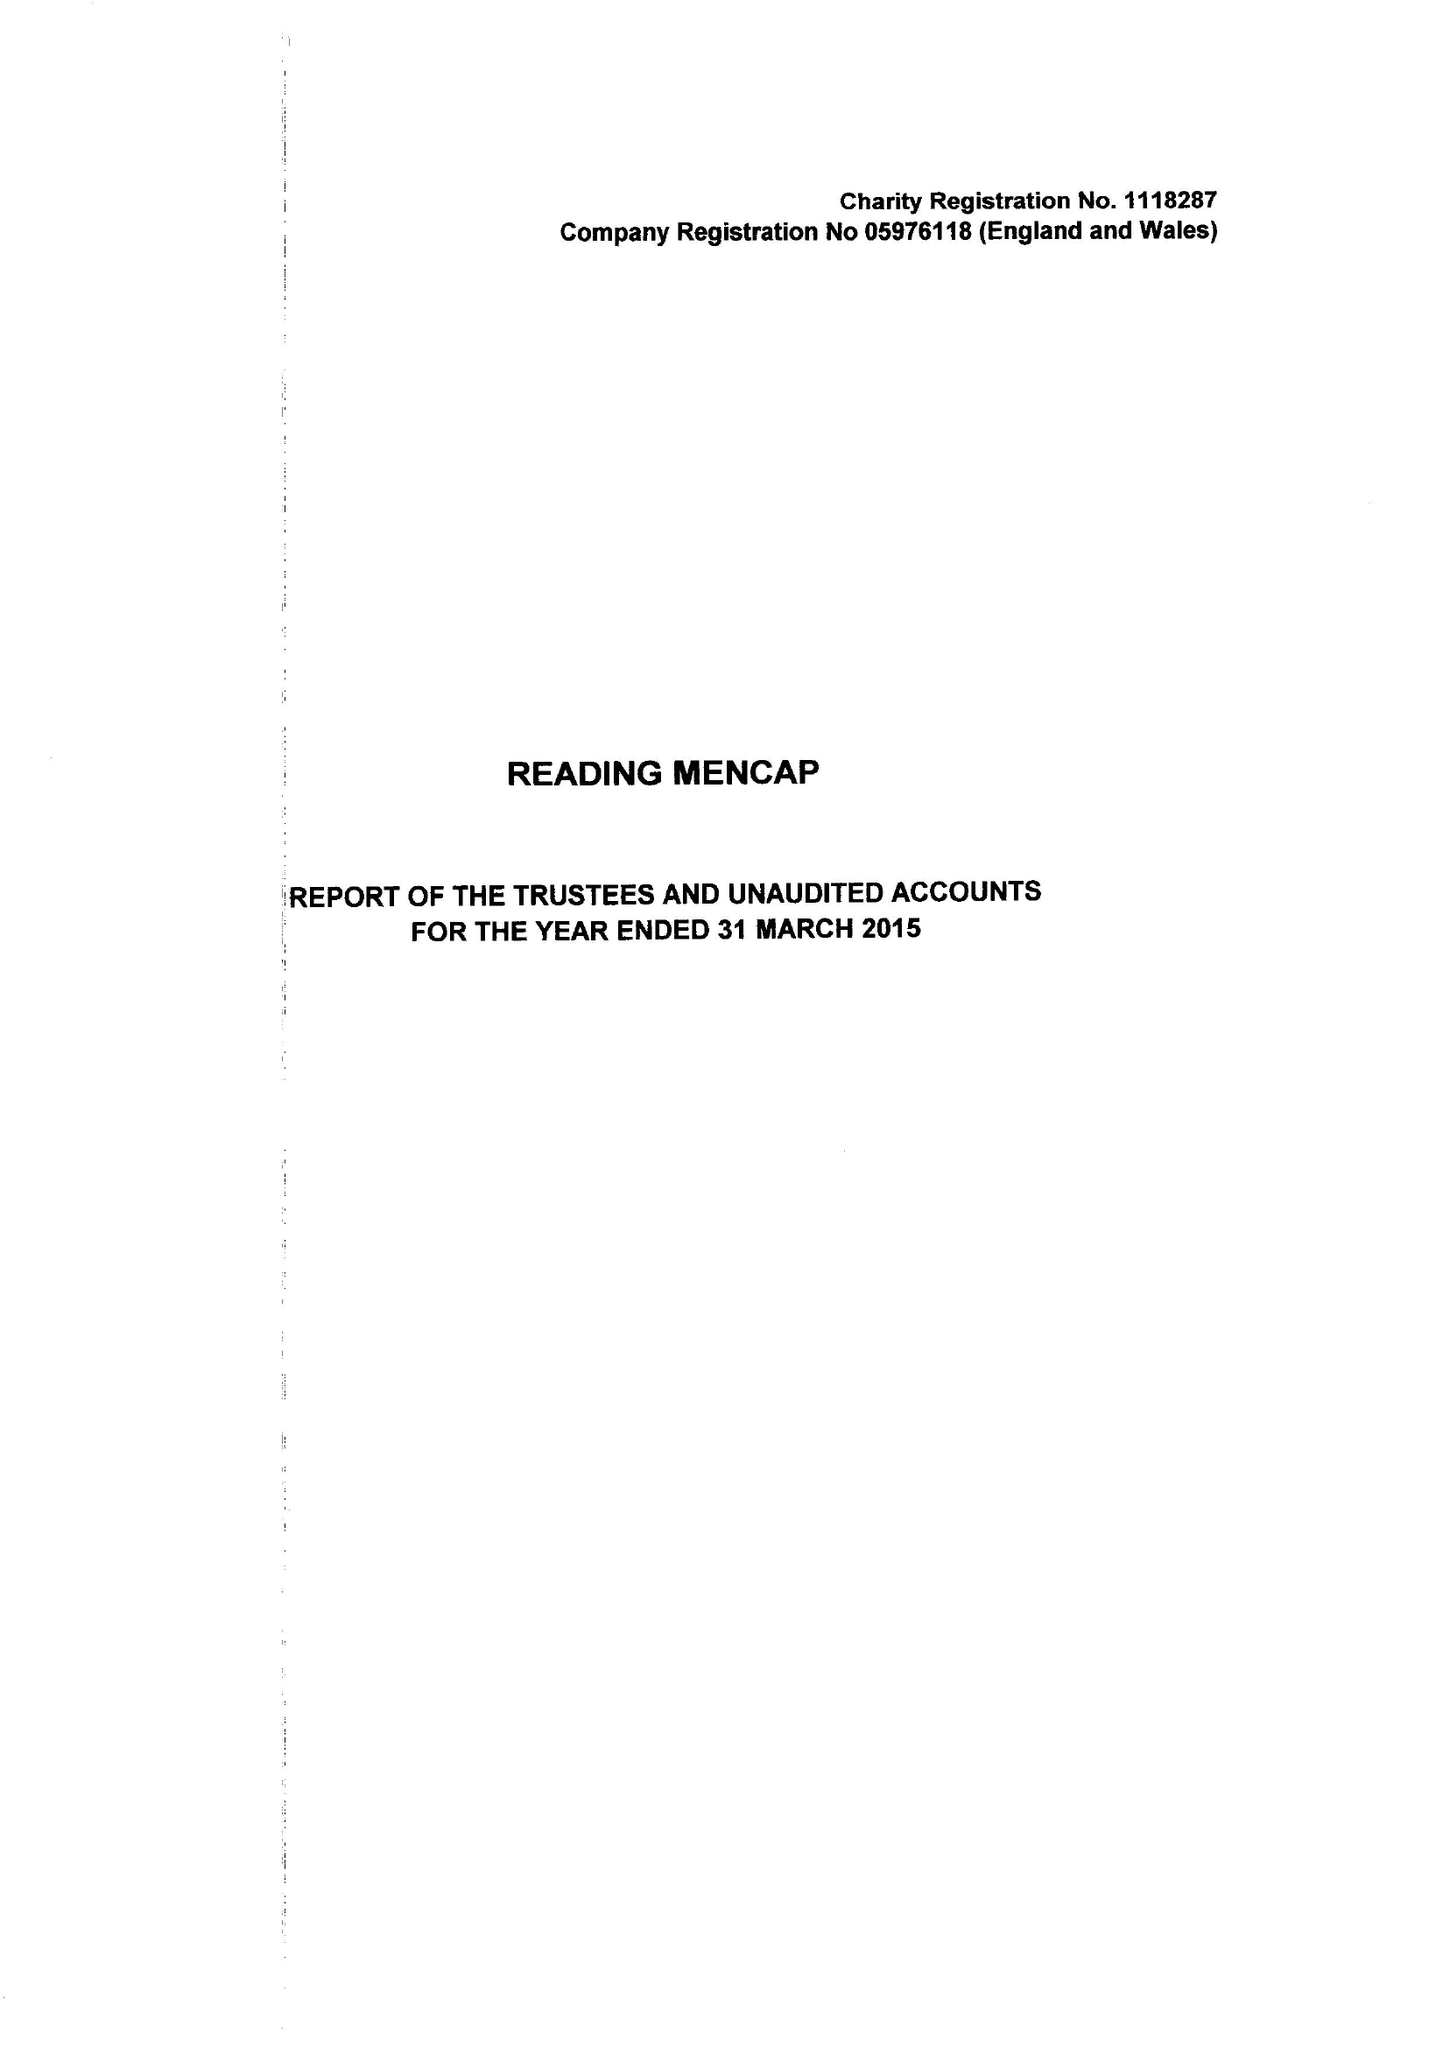What is the value for the address__post_town?
Answer the question using a single word or phrase. READING 